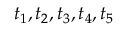<formula> <loc_0><loc_0><loc_500><loc_500>t _ { 1 } , t _ { 2 } , t _ { 3 } , t _ { 4 } , t _ { 5 }</formula> 